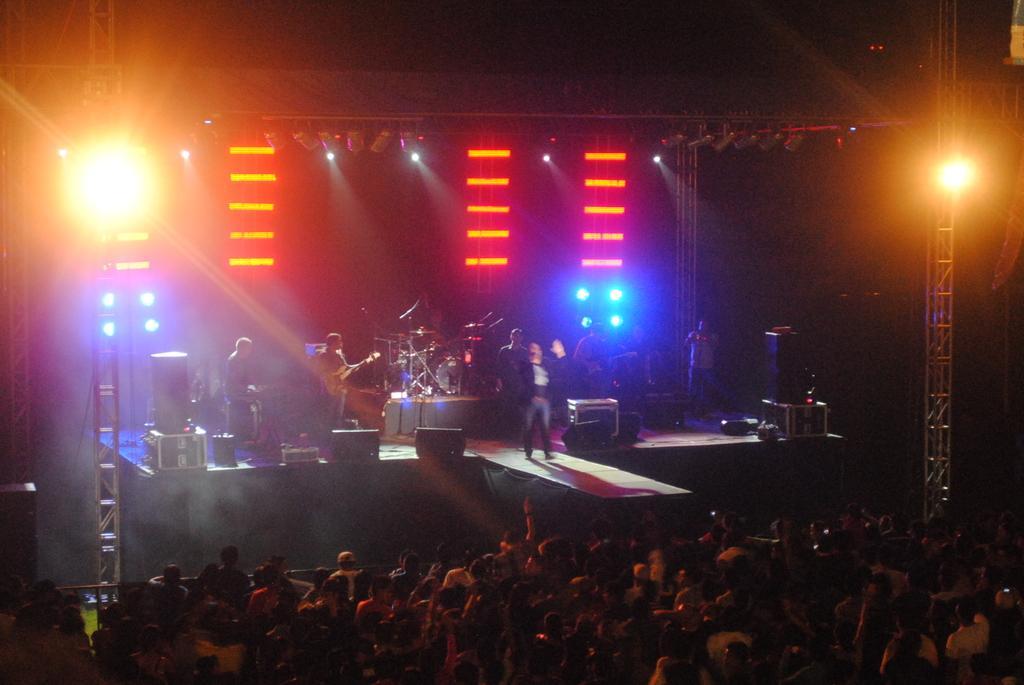Please provide a concise description of this image. In this image there are many people standing. In front of them there is a dais. There are a few musicians standing on the dais. In the center there is a person standing and holding a microphone in his hand. There are microphones, speakers, boxes and drums on the dais. In the background there is a wall. There are spotlights in the image. The image is dark. 